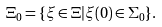Convert formula to latex. <formula><loc_0><loc_0><loc_500><loc_500>\Xi _ { 0 } = \{ \xi \in \Xi | \xi ( 0 ) \in \Sigma _ { 0 } \} .</formula> 